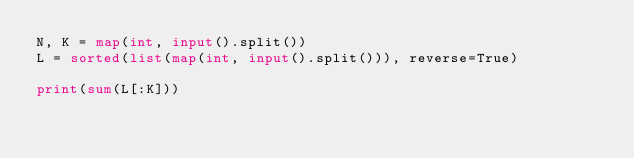Convert code to text. <code><loc_0><loc_0><loc_500><loc_500><_Python_>N, K = map(int, input().split())
L = sorted(list(map(int, input().split())), reverse=True)

print(sum(L[:K]))
</code> 